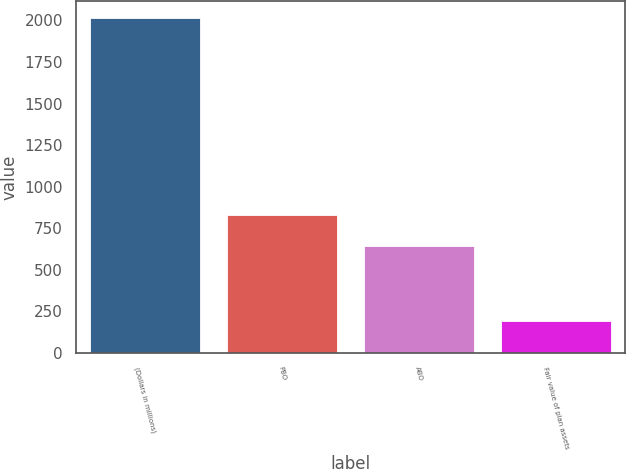Convert chart to OTSL. <chart><loc_0><loc_0><loc_500><loc_500><bar_chart><fcel>(Dollars in millions)<fcel>PBO<fcel>ABO<fcel>Fair value of plan assets<nl><fcel>2017<fcel>826.6<fcel>644<fcel>191<nl></chart> 